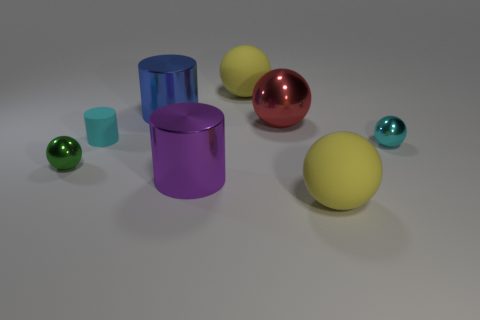Are there more big red things right of the blue metal thing than spheres?
Provide a succinct answer. No. Are there any other things that have the same material as the big red object?
Keep it short and to the point. Yes. Do the small object right of the big blue object and the big metal thing in front of the large red ball have the same color?
Offer a terse response. No. There is a yellow object to the left of the yellow sphere in front of the small shiny sphere that is in front of the tiny cyan shiny thing; what is its material?
Provide a succinct answer. Rubber. Is the number of small things greater than the number of tiny green rubber objects?
Offer a terse response. Yes. Are there any other things that are the same color as the large metal sphere?
Provide a succinct answer. No. There is a green sphere that is the same material as the blue thing; what is its size?
Make the answer very short. Small. What material is the small cylinder?
Offer a very short reply. Rubber. How many red metal objects have the same size as the cyan shiny ball?
Give a very brief answer. 0. Is there a blue metallic thing that has the same shape as the red thing?
Make the answer very short. No. 